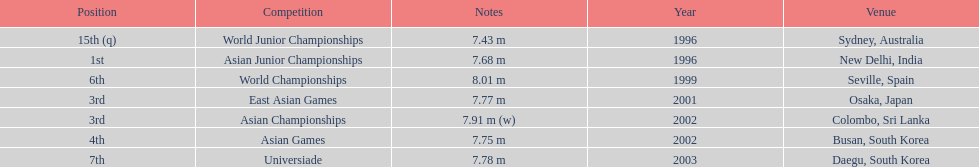What was the venue when he placed first? New Delhi, India. 